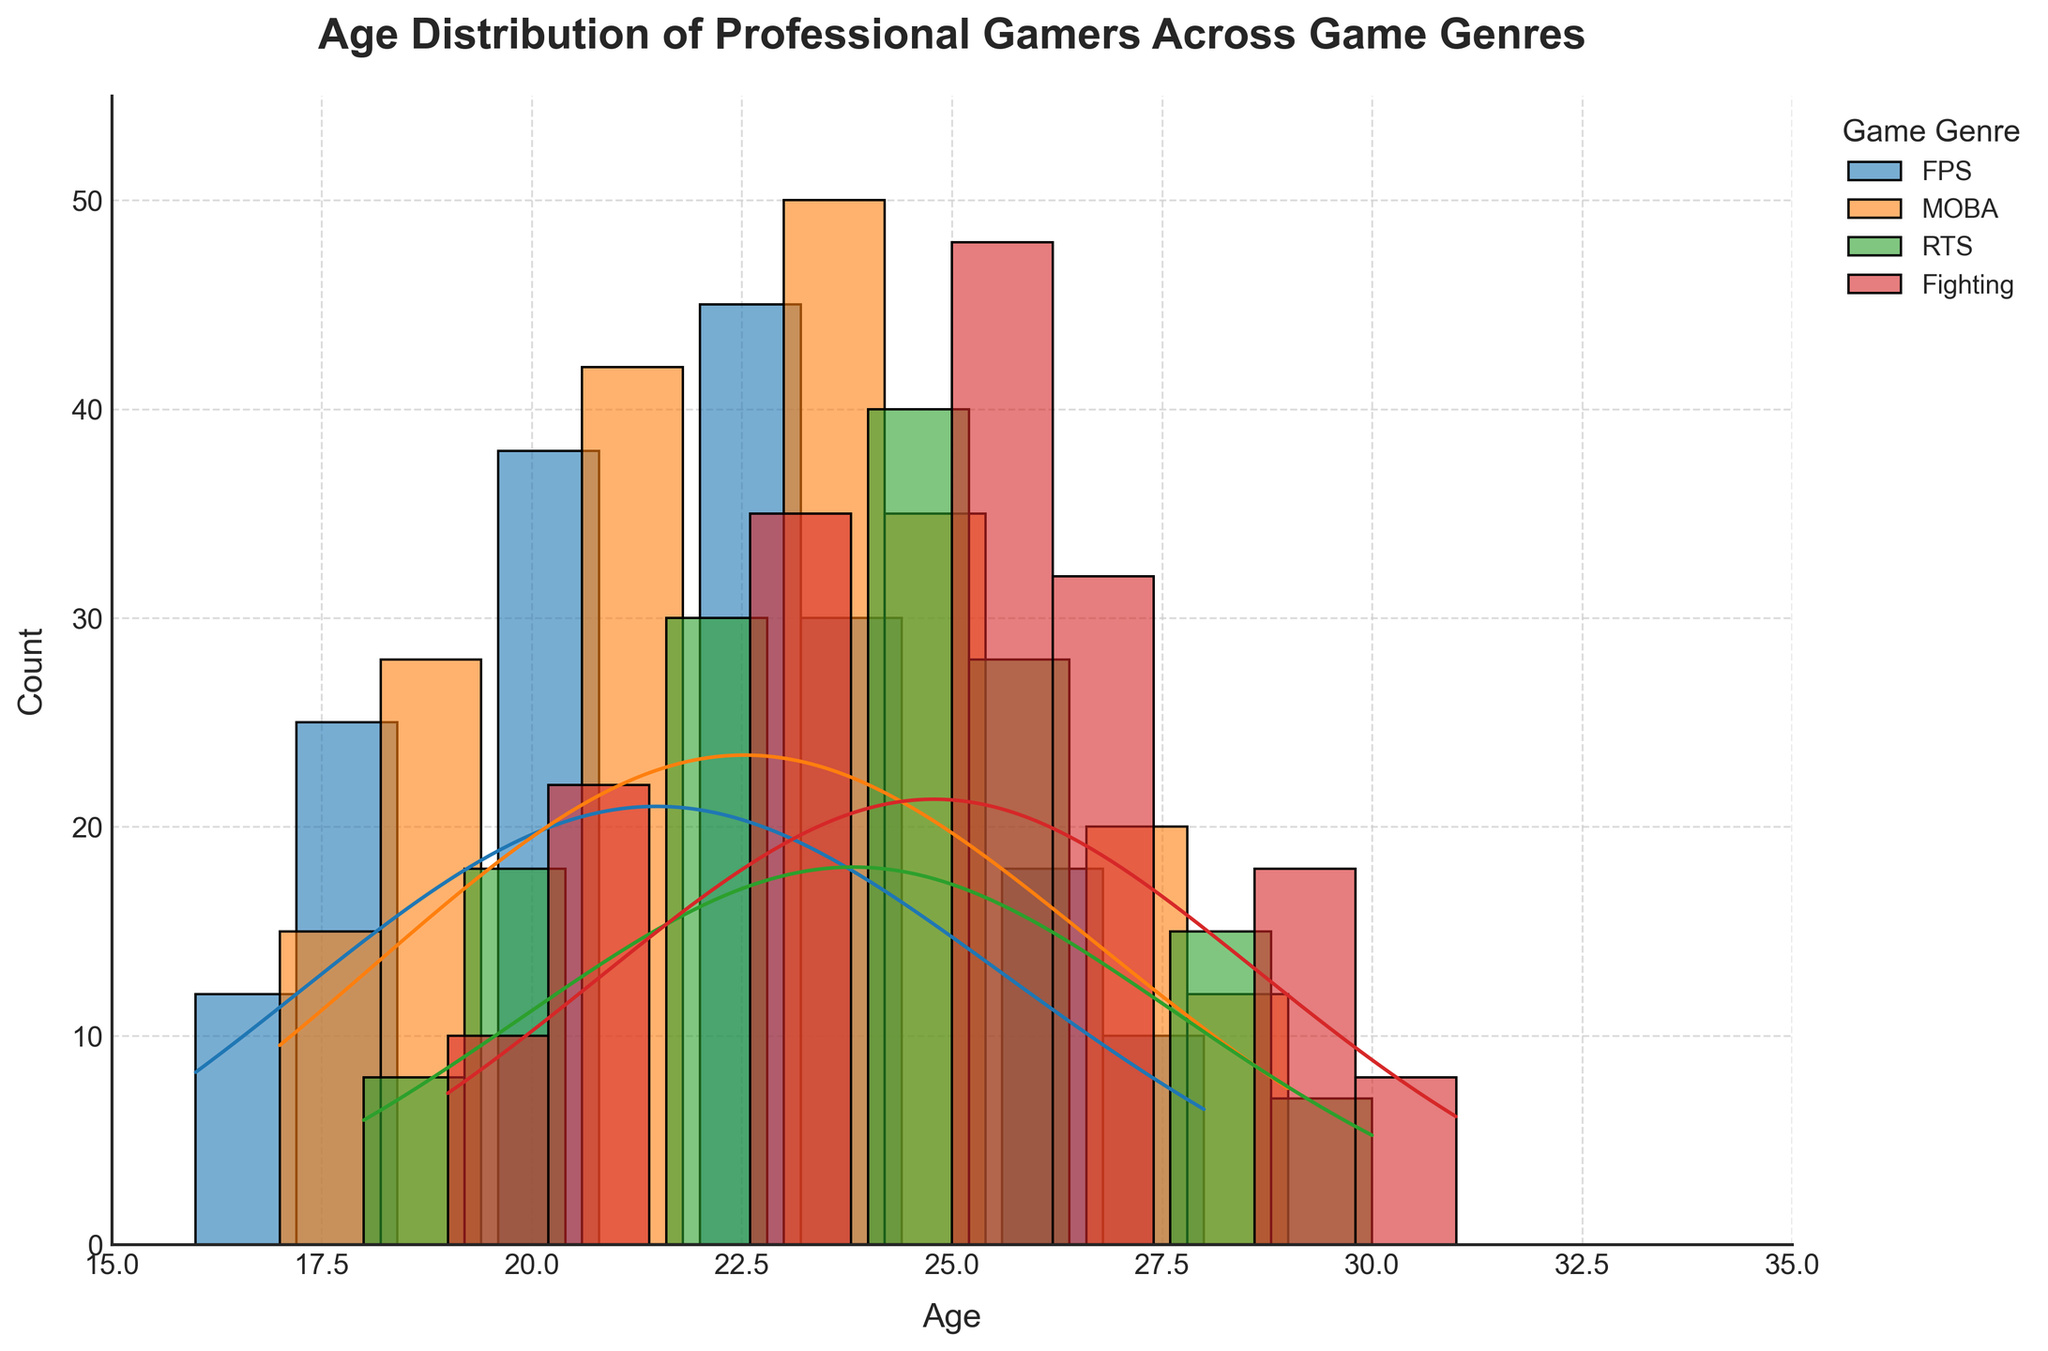what is the title of the figure? The title is located at the top of the figure and describes what the chart represents. In this case, it is regarding the age distribution of professional gamers.
Answer: Age Distribution of Professional Gamers Across Game Genres which axis represents age? The labels on the axes provide the information. The x-axis is labeled 'Age,' indicating it represents the age of the gamers.
Answer: x-axis which game genre has the highest peak density? By examining the KDE (density curve) for each genre, we identify which curve reaches the highest point. The MOBA curve peaks highest.
Answer: MOBA what is the age range covered in the figure? The x-axis shows the range of ages from the minimum to the maximum marked. The plot covers ages from 15 to 35.
Answer: 15 to 35 which age group has the highest frequency in FPS games? The histogram for FPS games displays the bar heights corresponding to different age groups. The highest bar is at age 22.
Answer: Age 22 how does the peak density for RTS compare to Fighting games? Comparing the KDE curves for both RTS and Fighting games, the RTS peak is higher than the Fighting peak.
Answer: RTS has a higher peak is the age distribution for MOBA wider or narrower compared to RTS? By comparing the spread of the KDE curves for both genres, the MOBA distribution is wider, covering a broader range of ages.
Answer: MOBA is wider what is the approximate count of professional gamers at age 20 for FPS games? Referring to the height of the bar at age 20 on the FPS histogram and considering the weights, it approximates to be 38.
Answer: 38 what do the KDE curves represent in this histogram? The KDE curves (or density curves) represent the smoothed distribution of ages for each game genre, indicating where the density of data points (ages) is highest.
Answer: Smoothed age distribution which genre shows a peak in density around age 25? By looking at where the KDE curves rise to a peak, we see that the MOBA genre has a peak around age 25.
Answer: MOBA 